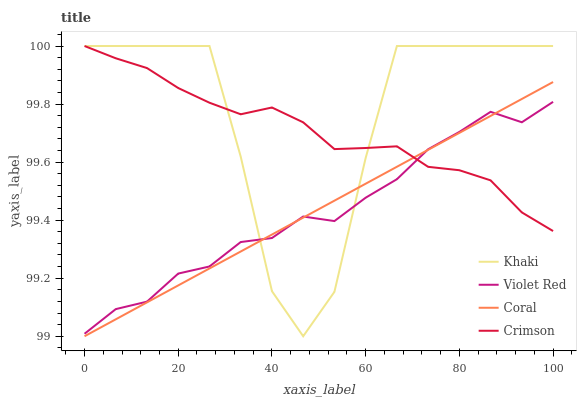Does Violet Red have the minimum area under the curve?
Answer yes or no. Yes. Does Khaki have the maximum area under the curve?
Answer yes or no. Yes. Does Khaki have the minimum area under the curve?
Answer yes or no. No. Does Violet Red have the maximum area under the curve?
Answer yes or no. No. Is Coral the smoothest?
Answer yes or no. Yes. Is Khaki the roughest?
Answer yes or no. Yes. Is Violet Red the smoothest?
Answer yes or no. No. Is Violet Red the roughest?
Answer yes or no. No. Does Coral have the lowest value?
Answer yes or no. Yes. Does Violet Red have the lowest value?
Answer yes or no. No. Does Khaki have the highest value?
Answer yes or no. Yes. Does Violet Red have the highest value?
Answer yes or no. No. Does Coral intersect Crimson?
Answer yes or no. Yes. Is Coral less than Crimson?
Answer yes or no. No. Is Coral greater than Crimson?
Answer yes or no. No. 